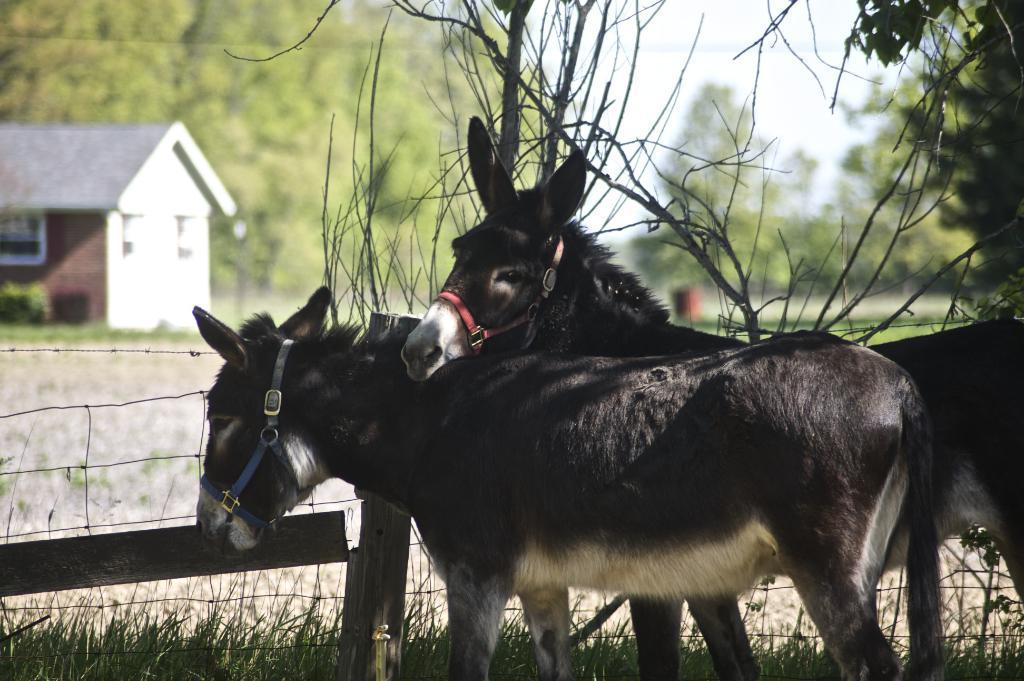Can you describe this image briefly? In the image there are two donkeys standing on the grassland inside a fence, on the left side there is a home on the background with trees behind it. 